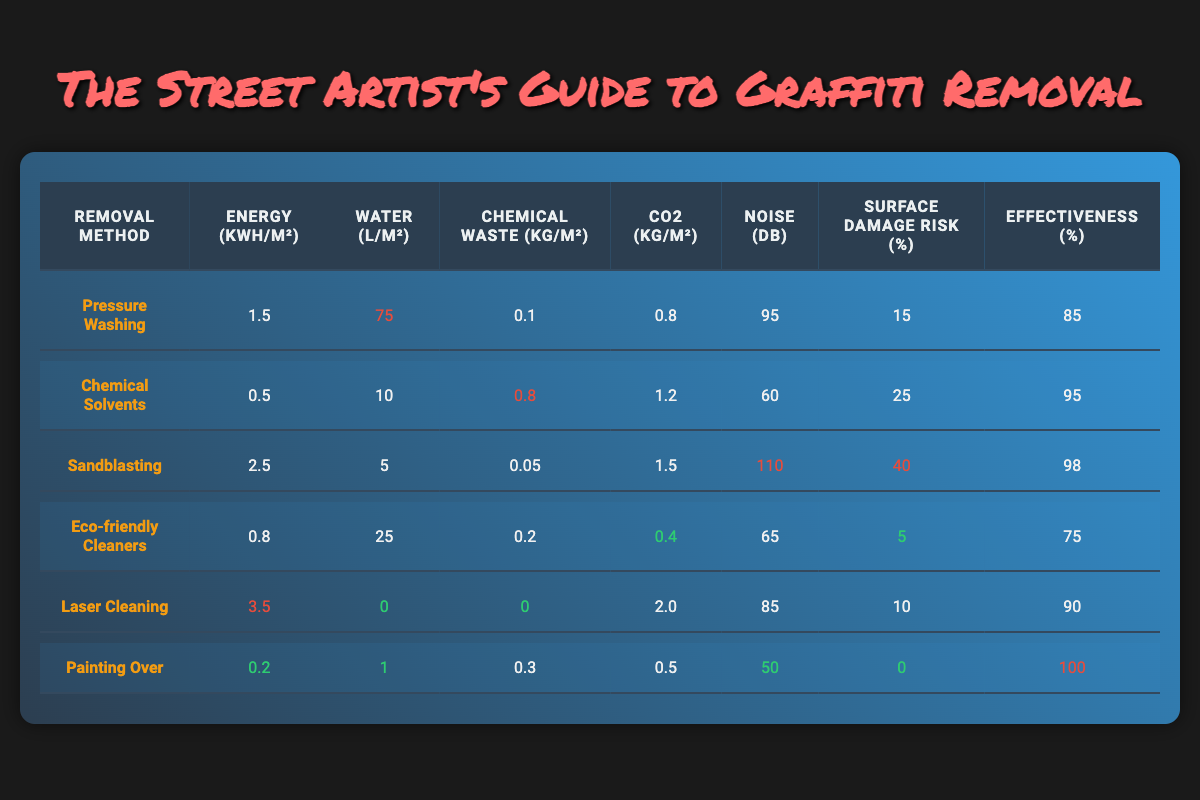What is the water usage for Chemical Solvents? According to the table, the water usage for Chemical Solvents is stated directly in the column for water usage, which shows 10 L/m².
Answer: 10 L/m² Which graffiti removal method has the lowest surface damage risk? The table shows surface damage risks as a percentage for each method. Painting Over has a surface damage risk of 0%, which is the lowest among all methods listed.
Answer: Painting Over What is the average energy consumption of all methods? To find the average energy consumption, add the energy values of all methods: 1.5 + 0.5 + 2.5 + 0.8 + 3.5 + 0.2 = 9.0 kWh/m². There are 6 methods, so the average is 9.0/6 = 1.5 kWh/m².
Answer: 1.5 kWh/m² Is the effectiveness of Sandblasting higher than that of Eco-friendly Cleaners? Looking at the effectiveness percentages, Sandblasting has an effectiveness of 98%, while Eco-friendly Cleaners have 75%. Since 98% is greater than 75%, the statement is true.
Answer: Yes How does the noise pollution of Laser Cleaning compare to that of Pressure Washing? Checking the noise pollution values, Laser Cleaning is at 85 dB and Pressure Washing is at 95 dB. Since 85 dB is less than 95 dB, Laser Cleaning has lower noise pollution than Pressure Washing.
Answer: Lower What is the total CO2 emissions from using Chemical Solvents and Eco-friendly Cleaners combined? For Chemical Solvents, the CO2 emissions are 1.2 kg/m² and for Eco-friendly Cleaners, it is 0.4 kg/m². Adding these gives: 1.2 + 0.4 = 1.6 kg/m² as the total emissions when both methods are combined.
Answer: 1.6 kg/m² Which method has the highest CO2 emissions? The table displays CO2 emissions for each method. Laser Cleaning has the highest value at 2.0 kg/m² compared to other methods listed, which shows it as the highest emissions method.
Answer: Laser Cleaning What percentage of surface damage risk is associated with Sandblasting compared to Painting Over? Sandblasting has a surface damage risk of 40%, while Painting Over has 0%. Comparing these, Sandblasting poses a considerably higher risk than Painting Over, confirming that the latter has none.
Answer: Sandblasting has higher risk Is the noise pollution of Eco-friendly Cleaners higher than that of Painting Over? The noise pollution values show Eco-friendly Cleaners at 65 dB and Painting Over at 50 dB. Since 65 dB is greater than 50 dB, Eco-friendly Cleaners indeed have higher noise pollution than Painting Over.
Answer: Yes 